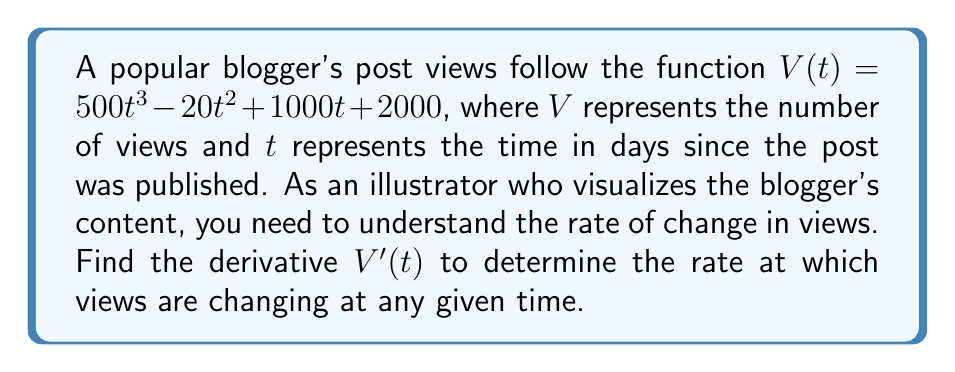Can you solve this math problem? To find the derivative of $V(t)$, we'll use the power rule and the constant rule:

1. For the term $500t^3$:
   $\frac{d}{dt}(500t^3) = 500 \cdot 3t^2 = 1500t^2$

2. For the term $-20t^2$:
   $\frac{d}{dt}(-20t^2) = -20 \cdot 2t = -40t$

3. For the term $1000t$:
   $\frac{d}{dt}(1000t) = 1000$

4. For the constant term $2000$:
   $\frac{d}{dt}(2000) = 0$

Now, we combine these results:

$V'(t) = 1500t^2 - 40t + 1000 + 0$

Simplifying:

$V'(t) = 1500t^2 - 40t + 1000$

This derivative represents the rate of change in views at any given time $t$.
Answer: $V'(t) = 1500t^2 - 40t + 1000$ 